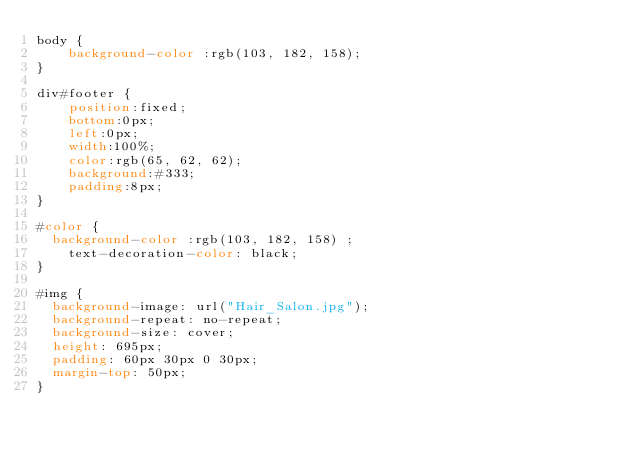<code> <loc_0><loc_0><loc_500><loc_500><_CSS_>body {
	background-color :rgb(103, 182, 158);
}

div#footer {
	position:fixed;
	bottom:0px;
	left:0px;
	width:100%;
	color:rgb(65, 62, 62);
	background:#333;
	padding:8px;
}

#color {
  background-color :rgb(103, 182, 158) ; 
	text-decoration-color: black;
}

#img {
  background-image: url("Hair_Salon.jpg");
  background-repeat: no-repeat;
  background-size: cover;
  height: 695px;
  padding: 60px 30px 0 30px;
  margin-top: 50px;
}



</code> 